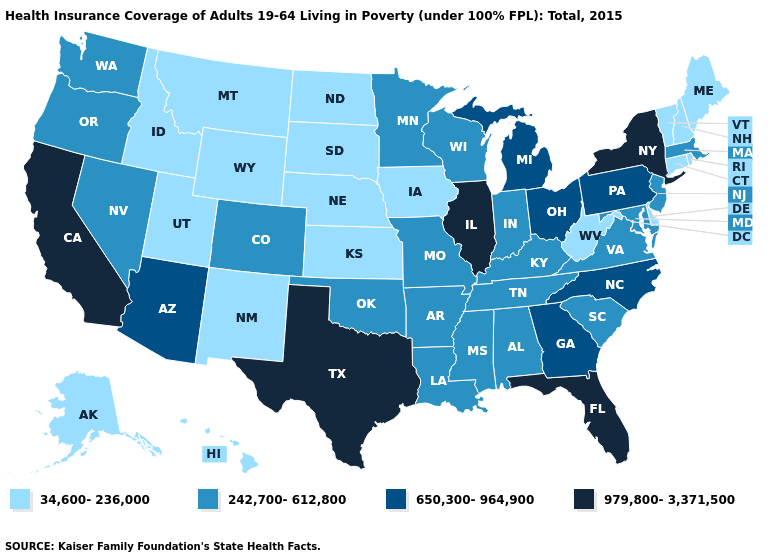What is the value of Kentucky?
Keep it brief. 242,700-612,800. What is the value of South Carolina?
Quick response, please. 242,700-612,800. What is the value of Indiana?
Give a very brief answer. 242,700-612,800. Does Colorado have the same value as Oklahoma?
Short answer required. Yes. What is the value of Wyoming?
Short answer required. 34,600-236,000. Which states have the lowest value in the USA?
Keep it brief. Alaska, Connecticut, Delaware, Hawaii, Idaho, Iowa, Kansas, Maine, Montana, Nebraska, New Hampshire, New Mexico, North Dakota, Rhode Island, South Dakota, Utah, Vermont, West Virginia, Wyoming. Name the states that have a value in the range 242,700-612,800?
Concise answer only. Alabama, Arkansas, Colorado, Indiana, Kentucky, Louisiana, Maryland, Massachusetts, Minnesota, Mississippi, Missouri, Nevada, New Jersey, Oklahoma, Oregon, South Carolina, Tennessee, Virginia, Washington, Wisconsin. Name the states that have a value in the range 650,300-964,900?
Answer briefly. Arizona, Georgia, Michigan, North Carolina, Ohio, Pennsylvania. Name the states that have a value in the range 34,600-236,000?
Be succinct. Alaska, Connecticut, Delaware, Hawaii, Idaho, Iowa, Kansas, Maine, Montana, Nebraska, New Hampshire, New Mexico, North Dakota, Rhode Island, South Dakota, Utah, Vermont, West Virginia, Wyoming. Does Mississippi have the same value as Rhode Island?
Give a very brief answer. No. What is the highest value in the MidWest ?
Give a very brief answer. 979,800-3,371,500. Among the states that border Nevada , does Arizona have the highest value?
Quick response, please. No. Which states hav the highest value in the West?
Quick response, please. California. What is the value of Maine?
Concise answer only. 34,600-236,000. Is the legend a continuous bar?
Short answer required. No. 